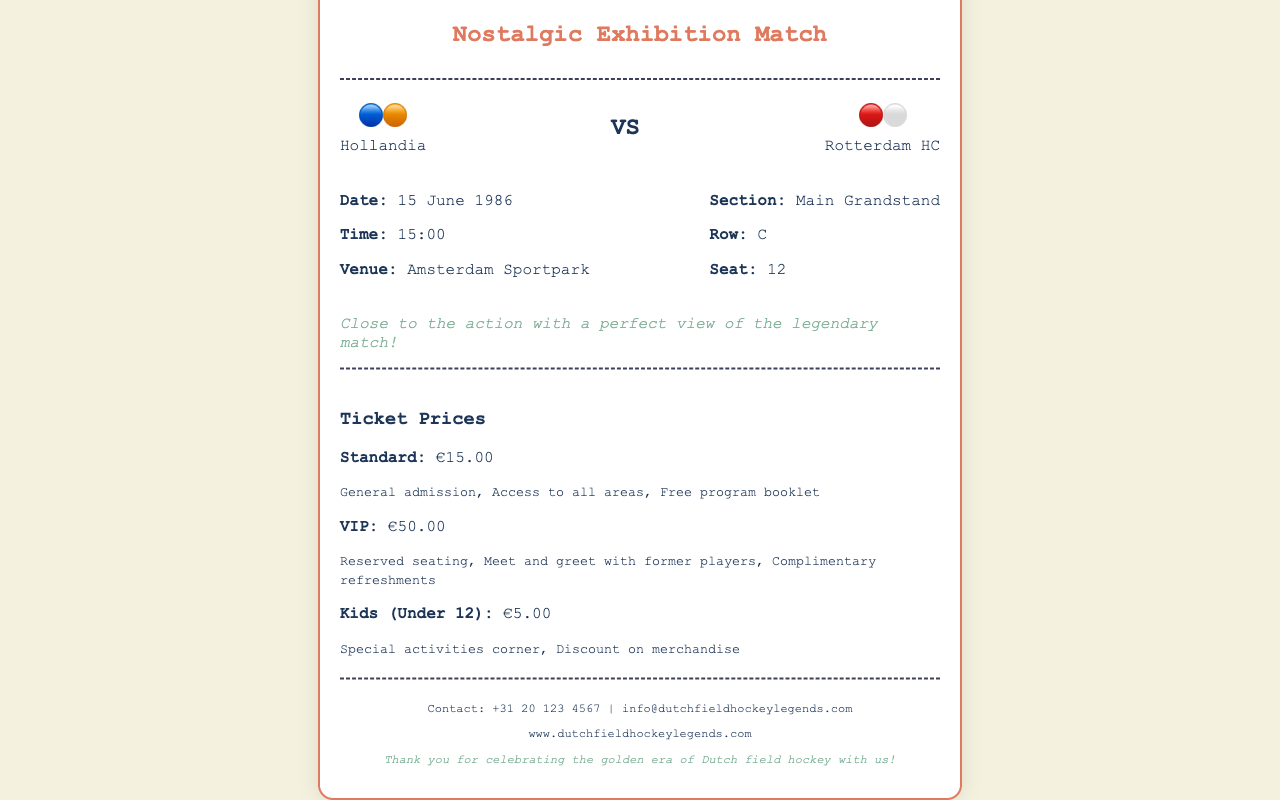What is the date of the match? The date of the match is clearly stated in the document.
Answer: 15 June 1986 What is the time of the match? The time is provided in the details section of the ticket.
Answer: 15:00 Which teams are playing in the match? The teams are listed in the match info section of the document.
Answer: Hollandia and Rotterdam HC What is the price of a VIP ticket? The ticket pricing section specifies the cost of different ticket types, including VIP.
Answer: €50.00 Where is the match being held? The venue is mentioned in the details section of the document.
Answer: Amsterdam Sportpark What row is the seat located in? The row information is clearly stated in the details section.
Answer: C How much does a Kids ticket cost? The document provides the price for the Kids ticket in the pricing section.
Answer: €5.00 What is included in the standard ticket? The benefits of the standard ticket are outlined in the pricing section.
Answer: General admission, Access to all areas, Free program booklet What is the contact email listed in the document? The contact details section includes an email address for inquiries.
Answer: info@dutchfieldhockeylegends.com 